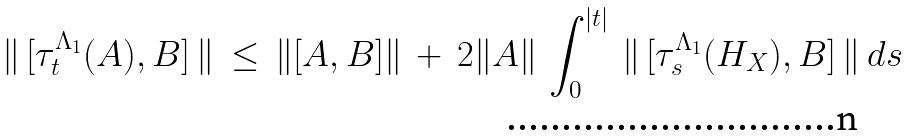Convert formula to latex. <formula><loc_0><loc_0><loc_500><loc_500>\| \, [ \tau _ { t } ^ { \Lambda _ { 1 } } ( A ) , B ] \, \| \, \leq \, \| [ A , B ] \| \, + \, 2 \| A \| \, \int _ { 0 } ^ { | t | } \, \| \, [ \tau _ { s } ^ { \Lambda _ { 1 } } ( H _ { X } ) , B ] \, \| \, d s</formula> 